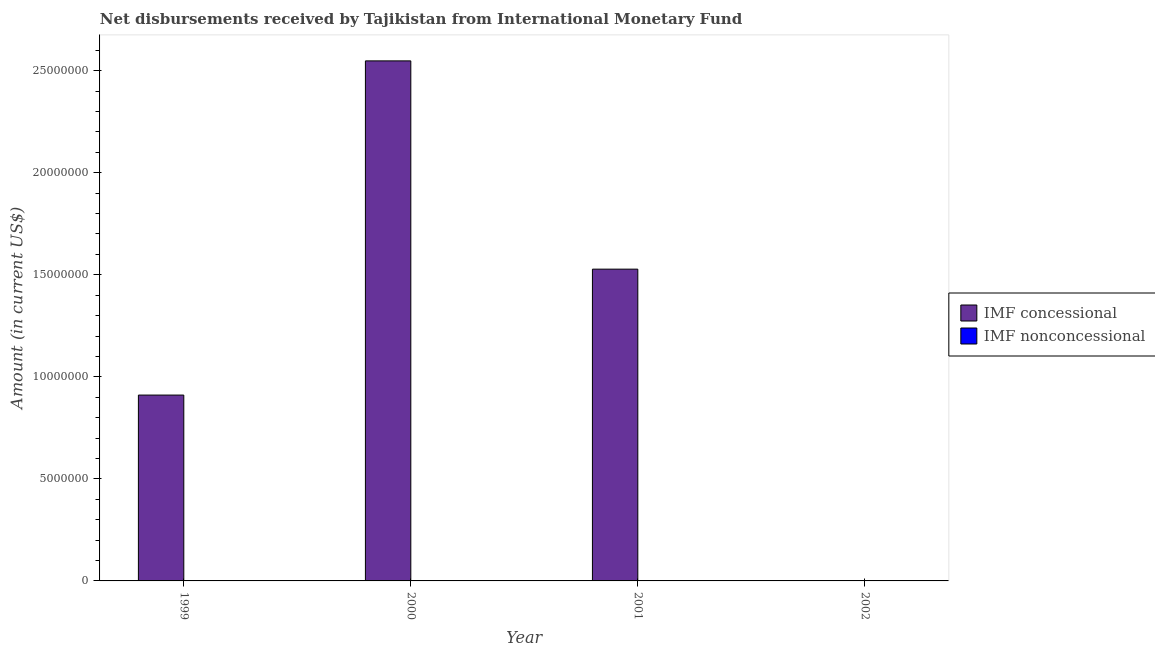How many bars are there on the 2nd tick from the left?
Give a very brief answer. 1. What is the label of the 1st group of bars from the left?
Offer a terse response. 1999. In how many cases, is the number of bars for a given year not equal to the number of legend labels?
Provide a succinct answer. 4. Across all years, what is the maximum net concessional disbursements from imf?
Keep it short and to the point. 2.55e+07. Across all years, what is the minimum net non concessional disbursements from imf?
Keep it short and to the point. 0. What is the total net non concessional disbursements from imf in the graph?
Provide a succinct answer. 0. What is the difference between the net concessional disbursements from imf in 1999 and that in 2000?
Ensure brevity in your answer.  -1.64e+07. What is the average net concessional disbursements from imf per year?
Keep it short and to the point. 1.25e+07. In the year 1999, what is the difference between the net concessional disbursements from imf and net non concessional disbursements from imf?
Keep it short and to the point. 0. In how many years, is the net concessional disbursements from imf greater than 16000000 US$?
Offer a terse response. 1. What is the ratio of the net concessional disbursements from imf in 2000 to that in 2001?
Provide a short and direct response. 1.67. Is the net concessional disbursements from imf in 2000 less than that in 2001?
Offer a terse response. No. What is the difference between the highest and the second highest net concessional disbursements from imf?
Your answer should be very brief. 1.02e+07. What is the difference between the highest and the lowest net concessional disbursements from imf?
Provide a short and direct response. 2.55e+07. In how many years, is the net non concessional disbursements from imf greater than the average net non concessional disbursements from imf taken over all years?
Offer a very short reply. 0. Are all the bars in the graph horizontal?
Make the answer very short. No. How many years are there in the graph?
Your response must be concise. 4. What is the difference between two consecutive major ticks on the Y-axis?
Provide a succinct answer. 5.00e+06. Does the graph contain any zero values?
Provide a short and direct response. Yes. Does the graph contain grids?
Make the answer very short. No. Where does the legend appear in the graph?
Offer a very short reply. Center right. How many legend labels are there?
Provide a short and direct response. 2. How are the legend labels stacked?
Give a very brief answer. Vertical. What is the title of the graph?
Ensure brevity in your answer.  Net disbursements received by Tajikistan from International Monetary Fund. Does "Highest 20% of population" appear as one of the legend labels in the graph?
Give a very brief answer. No. What is the Amount (in current US$) of IMF concessional in 1999?
Your answer should be compact. 9.11e+06. What is the Amount (in current US$) in IMF nonconcessional in 1999?
Ensure brevity in your answer.  0. What is the Amount (in current US$) of IMF concessional in 2000?
Provide a succinct answer. 2.55e+07. What is the Amount (in current US$) in IMF concessional in 2001?
Your answer should be compact. 1.53e+07. What is the Amount (in current US$) of IMF nonconcessional in 2001?
Ensure brevity in your answer.  0. Across all years, what is the maximum Amount (in current US$) in IMF concessional?
Offer a very short reply. 2.55e+07. What is the total Amount (in current US$) of IMF concessional in the graph?
Your answer should be very brief. 4.99e+07. What is the difference between the Amount (in current US$) of IMF concessional in 1999 and that in 2000?
Provide a short and direct response. -1.64e+07. What is the difference between the Amount (in current US$) in IMF concessional in 1999 and that in 2001?
Give a very brief answer. -6.17e+06. What is the difference between the Amount (in current US$) in IMF concessional in 2000 and that in 2001?
Keep it short and to the point. 1.02e+07. What is the average Amount (in current US$) of IMF concessional per year?
Ensure brevity in your answer.  1.25e+07. What is the average Amount (in current US$) of IMF nonconcessional per year?
Provide a short and direct response. 0. What is the ratio of the Amount (in current US$) of IMF concessional in 1999 to that in 2000?
Provide a short and direct response. 0.36. What is the ratio of the Amount (in current US$) in IMF concessional in 1999 to that in 2001?
Give a very brief answer. 0.6. What is the ratio of the Amount (in current US$) in IMF concessional in 2000 to that in 2001?
Your answer should be very brief. 1.67. What is the difference between the highest and the second highest Amount (in current US$) of IMF concessional?
Your answer should be very brief. 1.02e+07. What is the difference between the highest and the lowest Amount (in current US$) in IMF concessional?
Ensure brevity in your answer.  2.55e+07. 